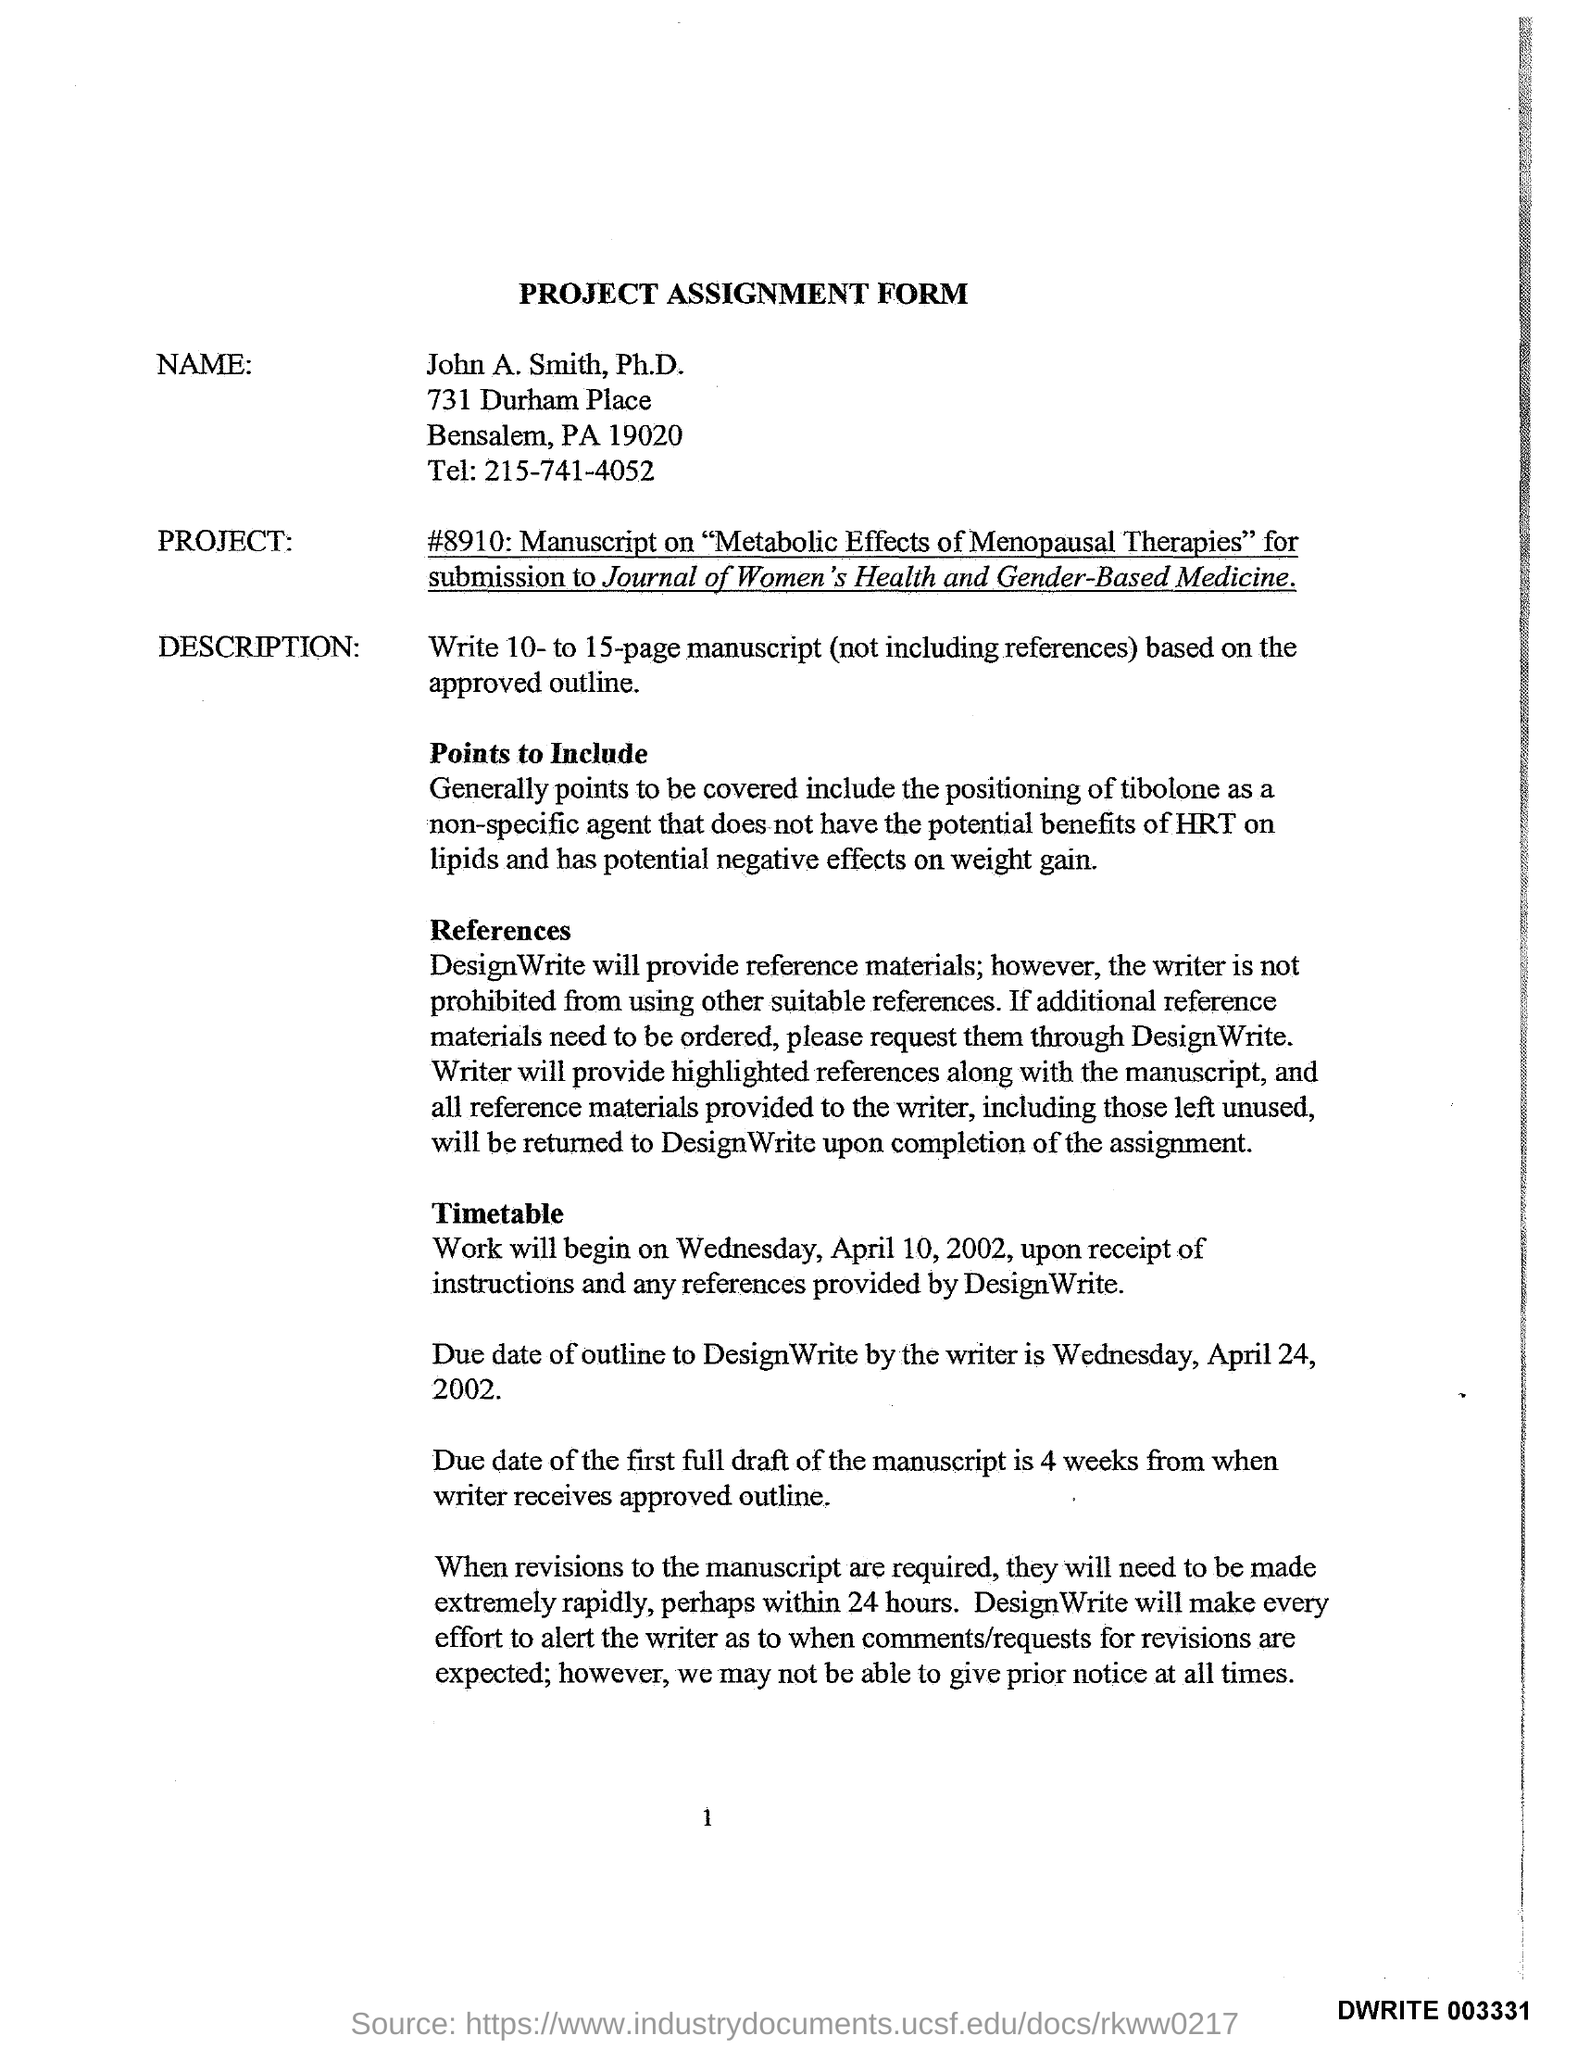List a handful of essential elements in this visual. The name mentioned in the document is John A. Smith, Ph.D. The document mentions a project assignment form. The telephone number is 215-741-4052. 